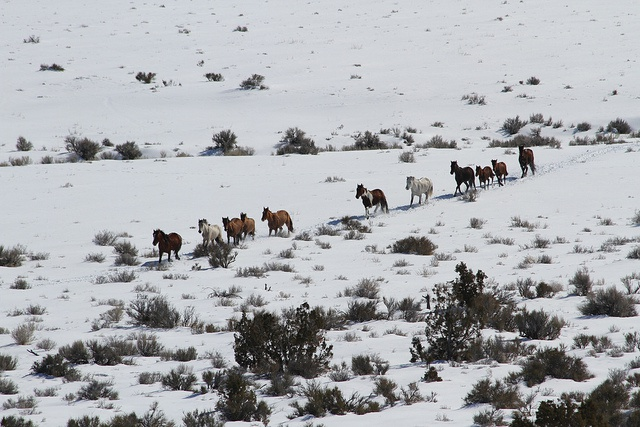Describe the objects in this image and their specific colors. I can see horse in lightgray, gray, black, and darkgray tones, horse in lightgray, black, gray, maroon, and darkgray tones, horse in lightgray, gray, darkgray, and black tones, horse in lightgray, black, maroon, and brown tones, and horse in lightgray, black, gray, darkgray, and maroon tones in this image. 